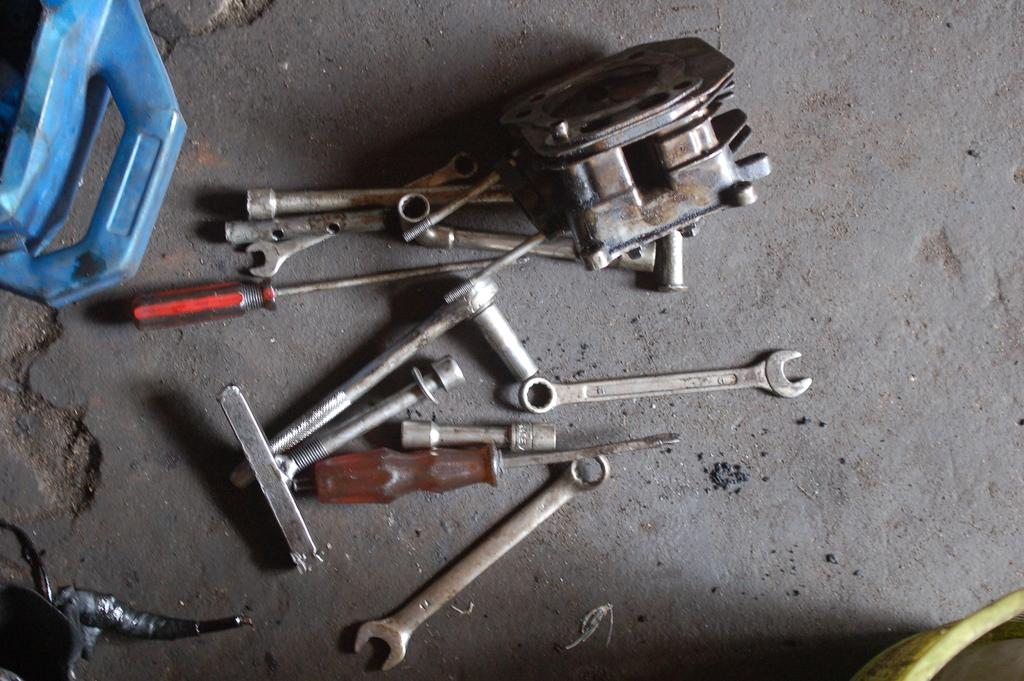What types of tools are visible in the image? There are screwdrivers, wrenches, and a metal hammer in the image. What else can be seen on the floor in the image? There are rods placed on the floor. Can you describe the unspecified object on the left side of the image? Unfortunately, the facts provided do not give any information about the object on the left side of the image. How are the tools arranged on the floor? The tools are placed on the floor, but the arrangement is not specified in the facts. What type of glass is being used to hold the idea in the image? There is no glass or idea present in the image; it features tools and rods placed on the floor. 